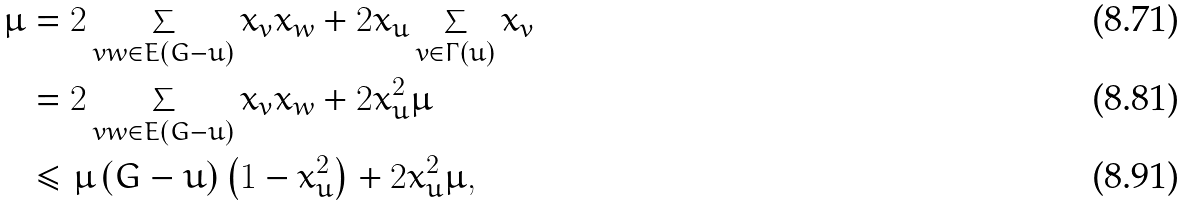<formula> <loc_0><loc_0><loc_500><loc_500>\mu & = 2 \sum _ { v w \in E \left ( G - u \right ) } x _ { v } x _ { w } + 2 x _ { u } \sum _ { v \in \Gamma \left ( u \right ) } x _ { v } \\ & = 2 \sum _ { v w \in E \left ( G - u \right ) } x _ { v } x _ { w } + 2 x _ { u } ^ { 2 } \mu \\ & \leq \mu \left ( G - u \right ) \left ( 1 - x _ { u } ^ { 2 } \right ) + 2 x _ { u } ^ { 2 } \mu ,</formula> 